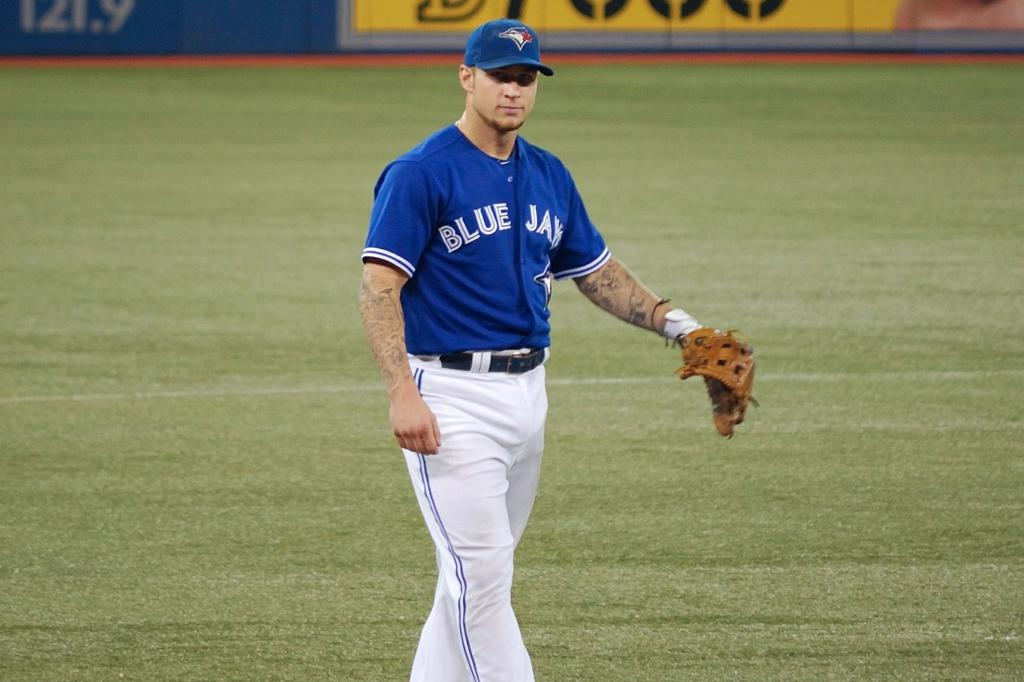<image>
Summarize the visual content of the image. A baseball player has a jersey with the name Blue Jays on it. 